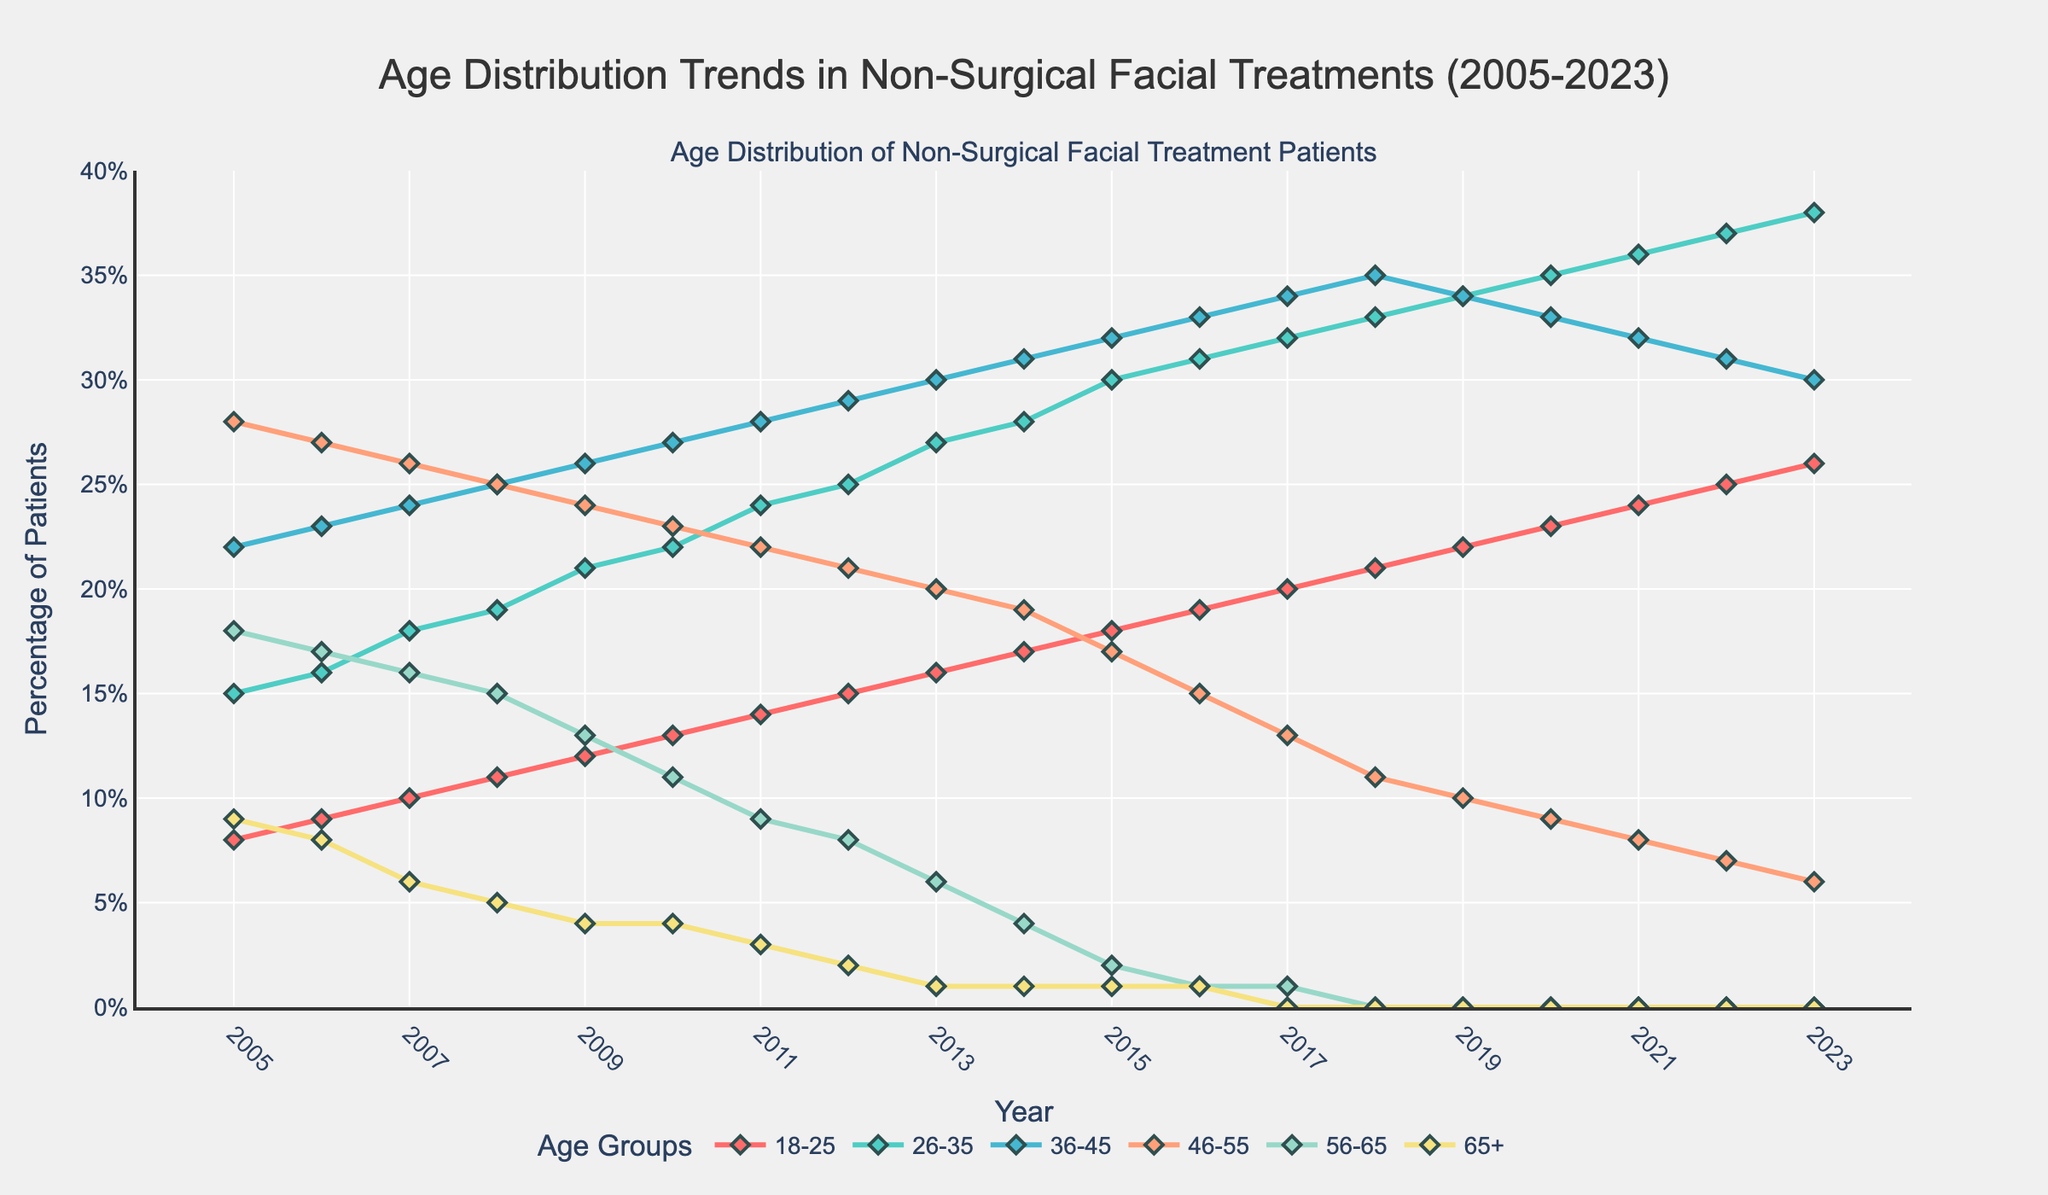What is the trend for the age group 18-25 from 2005 to 2023? The plot shows a clear upward trend in the percentage of patients aged 18-25 seeking non-surgical facial treatments over the years. The values start at 8 in 2005 and increase annually, reaching 26 in 2023.
Answer: Upward trend Which age group had the highest percentage of patients in 2023? By examining the endpoints of the lines for the year 2023, the age group 26-35 had the highest value at 38.
Answer: 26-35 How does the percentage of patients aged 56-65 change from 2005 to 2018? Observing the line for 56-65 from 2005 (18) to 2018 (0), it shows a consistent decrease over the years until it reaches 0 from 2018 onwards.
Answer: Consistent decrease to 0 What is the difference in percentage between the age groups 36-45 and 46-55 in 2022? In 2022, the percentage for 36-45 is 31 and for 46-55 is 7. Calculating the difference: 31 - 7 = 24.
Answer: 24 Which two age groups had an equal percentage of patients in 2019? Checking the values for 2019, the age groups 36-45 and 46-55 both have a value of 34.
Answer: 36-45 and 46-55 In which year did the age group 26-35 surpass the age group 46-55 in percentage? Looking at the intersection points of the lines for 26-35 and 46-55, 26-35 surpasses 46-55 between 2006 and 2007. Therefore, in 2006, 26-35 was still lower than 46-55, but in 2007 it surpassed.
Answer: 2007 What is the average percentage of patients aged 65+ from 2005 to 2023? Summing the values for the age group 65+ across 2005 (9), 2006 (8), 2007 (6), 2008 (5), 2009 (4), 2010 (4), 2011 (3), 2012 (2), 2013 (1), and from 2014 to 2023 (1,1,1,1,0,0,0,0,0,0), we get a total of 36 over 19 years. Average is 36/19 = 1.89.
Answer: 1.89 Between which two consecutive years did the age group 46-55 see the largest decrease in percentage? Evaluating the changes year-over-year for 46-55, the largest drop happens between 2015 (17) and 2016 (15). The decrease is 2.
Answer: 2015 to 2016 Which age group shows a consistent upward trend without any year of decrease? Observing each line, the age group 26-35 increases every single year from 2005 to 2023 without any decrease.
Answer: 26-35 